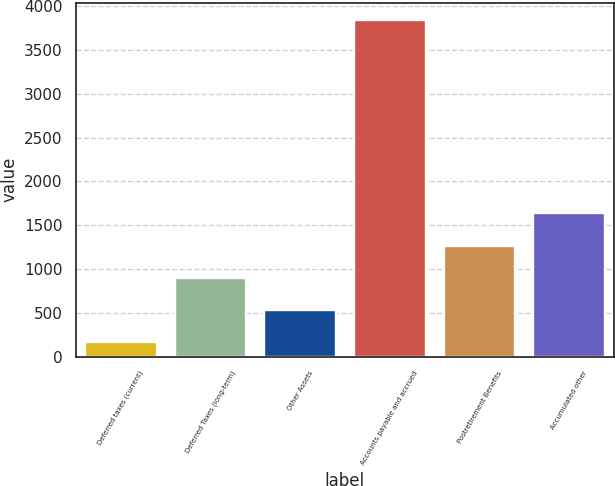Convert chart. <chart><loc_0><loc_0><loc_500><loc_500><bar_chart><fcel>Deferred taxes (current)<fcel>Deferred Taxes (long-term)<fcel>Other Assets<fcel>Accounts payable and accrued<fcel>Postretirement Benefits<fcel>Accumulated other<nl><fcel>163<fcel>900<fcel>531.5<fcel>3848<fcel>1268.5<fcel>1637<nl></chart> 